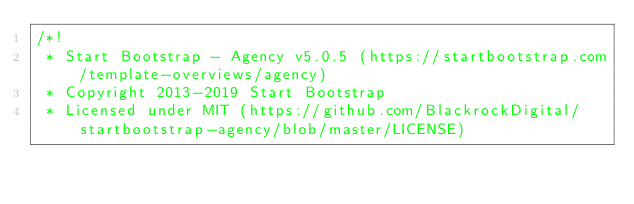<code> <loc_0><loc_0><loc_500><loc_500><_CSS_>/*!
 * Start Bootstrap - Agency v5.0.5 (https://startbootstrap.com/template-overviews/agency)
 * Copyright 2013-2019 Start Bootstrap
 * Licensed under MIT (https://github.com/BlackrockDigital/startbootstrap-agency/blob/master/LICENSE)</code> 